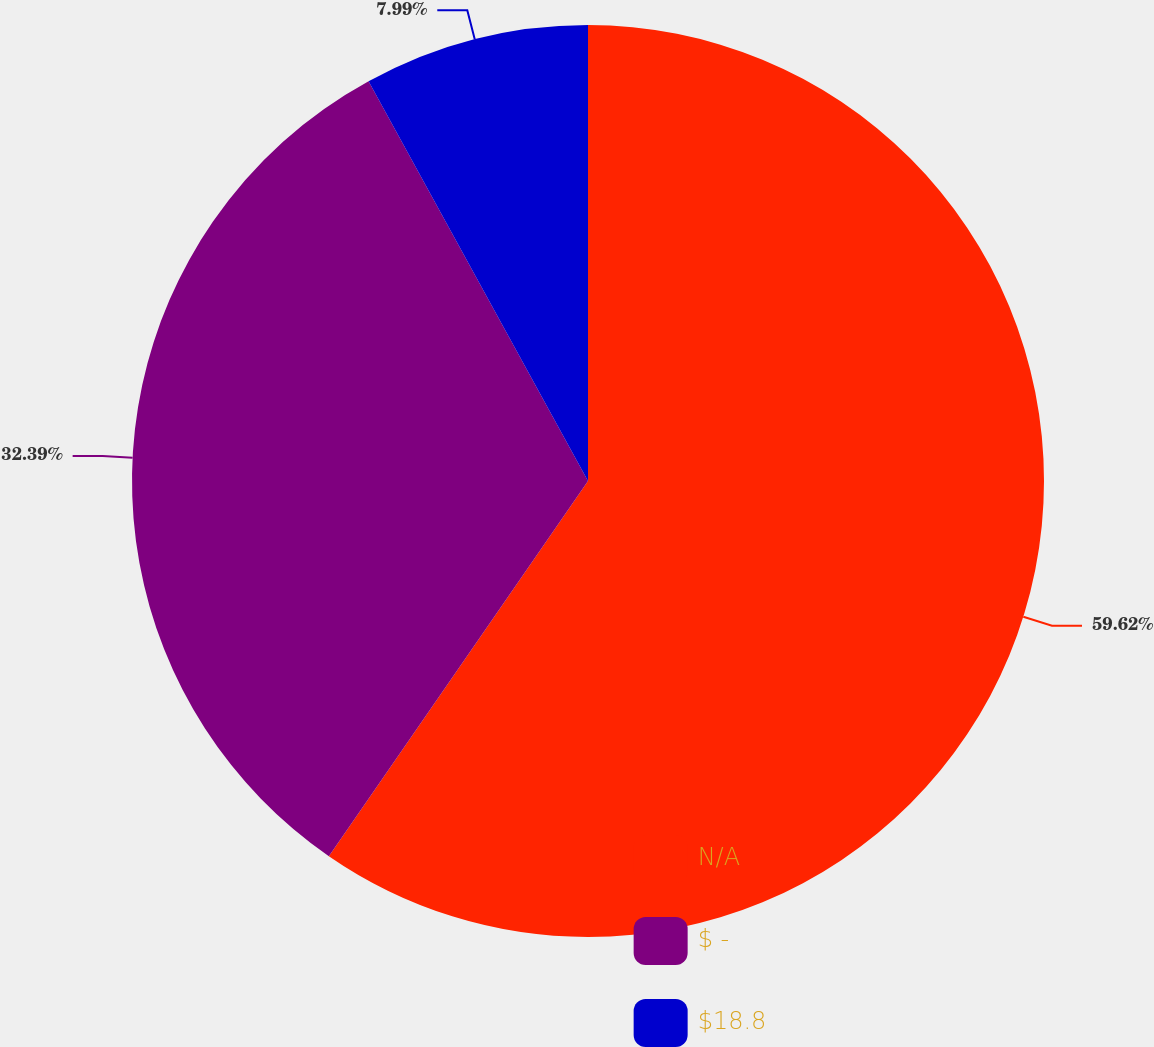Convert chart to OTSL. <chart><loc_0><loc_0><loc_500><loc_500><pie_chart><fcel>N/A<fcel>$ -<fcel>$18.8<nl><fcel>59.62%<fcel>32.39%<fcel>7.99%<nl></chart> 